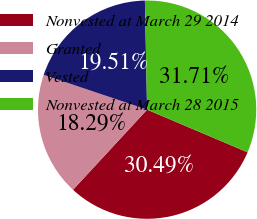<chart> <loc_0><loc_0><loc_500><loc_500><pie_chart><fcel>Nonvested at March 29 2014<fcel>Granted<fcel>Vested<fcel>Nonvested at March 28 2015<nl><fcel>30.49%<fcel>18.29%<fcel>19.51%<fcel>31.71%<nl></chart> 